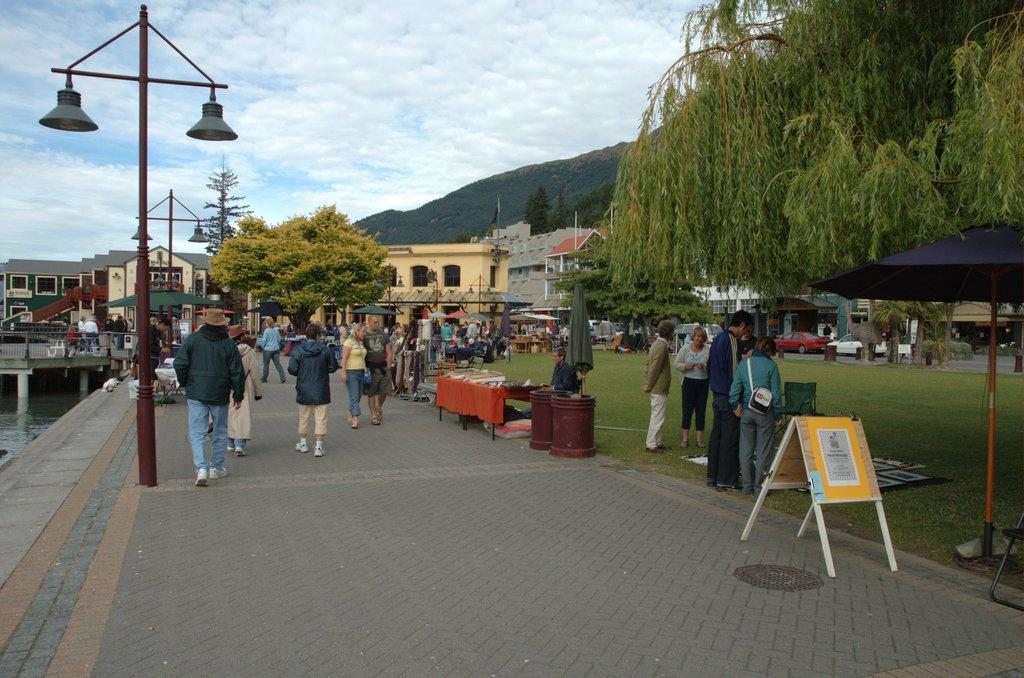How many people are in the group visible in the image? There is a group of people in the image, but the exact number cannot be determined from the provided facts. What type of structures are present in the image? There are stalls, a board, houses, and a bridge visible in the image. What objects are used for protection from the elements in the image? Umbrellas with poles are present in the image. What can be seen illuminated in the image? Lights are visible in the image. What type of decoration is present in the image? There is a flag in the image. What type of natural environment is present in the image? Trees, grass, water, and hills are visible in the image. What is visible in the background of the image? The sky is visible in the background of the image. Can you hear the whistle of the cherry as it joins the group in the image? There is no whistle, cherry, or indication of joining a group in the image. 